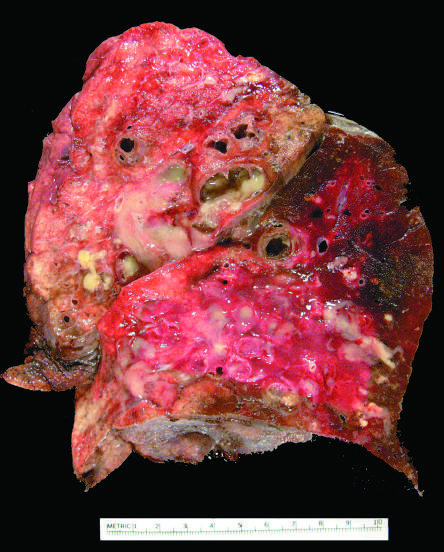what does the cut surface of lung show?
Answer the question using a single word or phrase. Markedly dilated bronchi filled with purulent mucus that extend to subpleural regions 